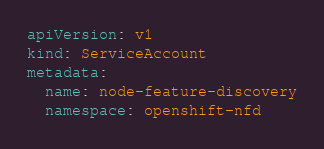<code> <loc_0><loc_0><loc_500><loc_500><_YAML_>apiVersion: v1
kind: ServiceAccount
metadata:
  name: node-feature-discovery
  namespace: openshift-nfd
</code> 